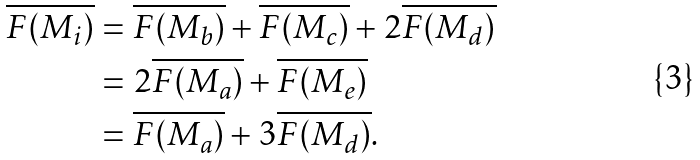<formula> <loc_0><loc_0><loc_500><loc_500>\overline { F ( M _ { i } ) } & = \overline { F ( M _ { b } ) } + \overline { F ( M _ { c } ) } + 2 \overline { F ( M _ { d } ) } \\ & = 2 \overline { F ( M _ { a } ) } + \overline { F ( M _ { e } ) } \\ & = \overline { F ( M _ { a } ) } + 3 \overline { F ( M _ { d } ) } .</formula> 